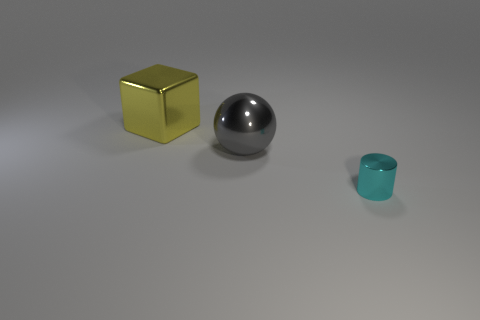Add 3 cyan cylinders. How many objects exist? 6 Subtract all blocks. How many objects are left? 2 Subtract all green balls. Subtract all large gray shiny balls. How many objects are left? 2 Add 2 tiny cyan objects. How many tiny cyan objects are left? 3 Add 1 small shiny cylinders. How many small shiny cylinders exist? 2 Subtract 0 blue cubes. How many objects are left? 3 Subtract 1 balls. How many balls are left? 0 Subtract all brown balls. Subtract all green blocks. How many balls are left? 1 